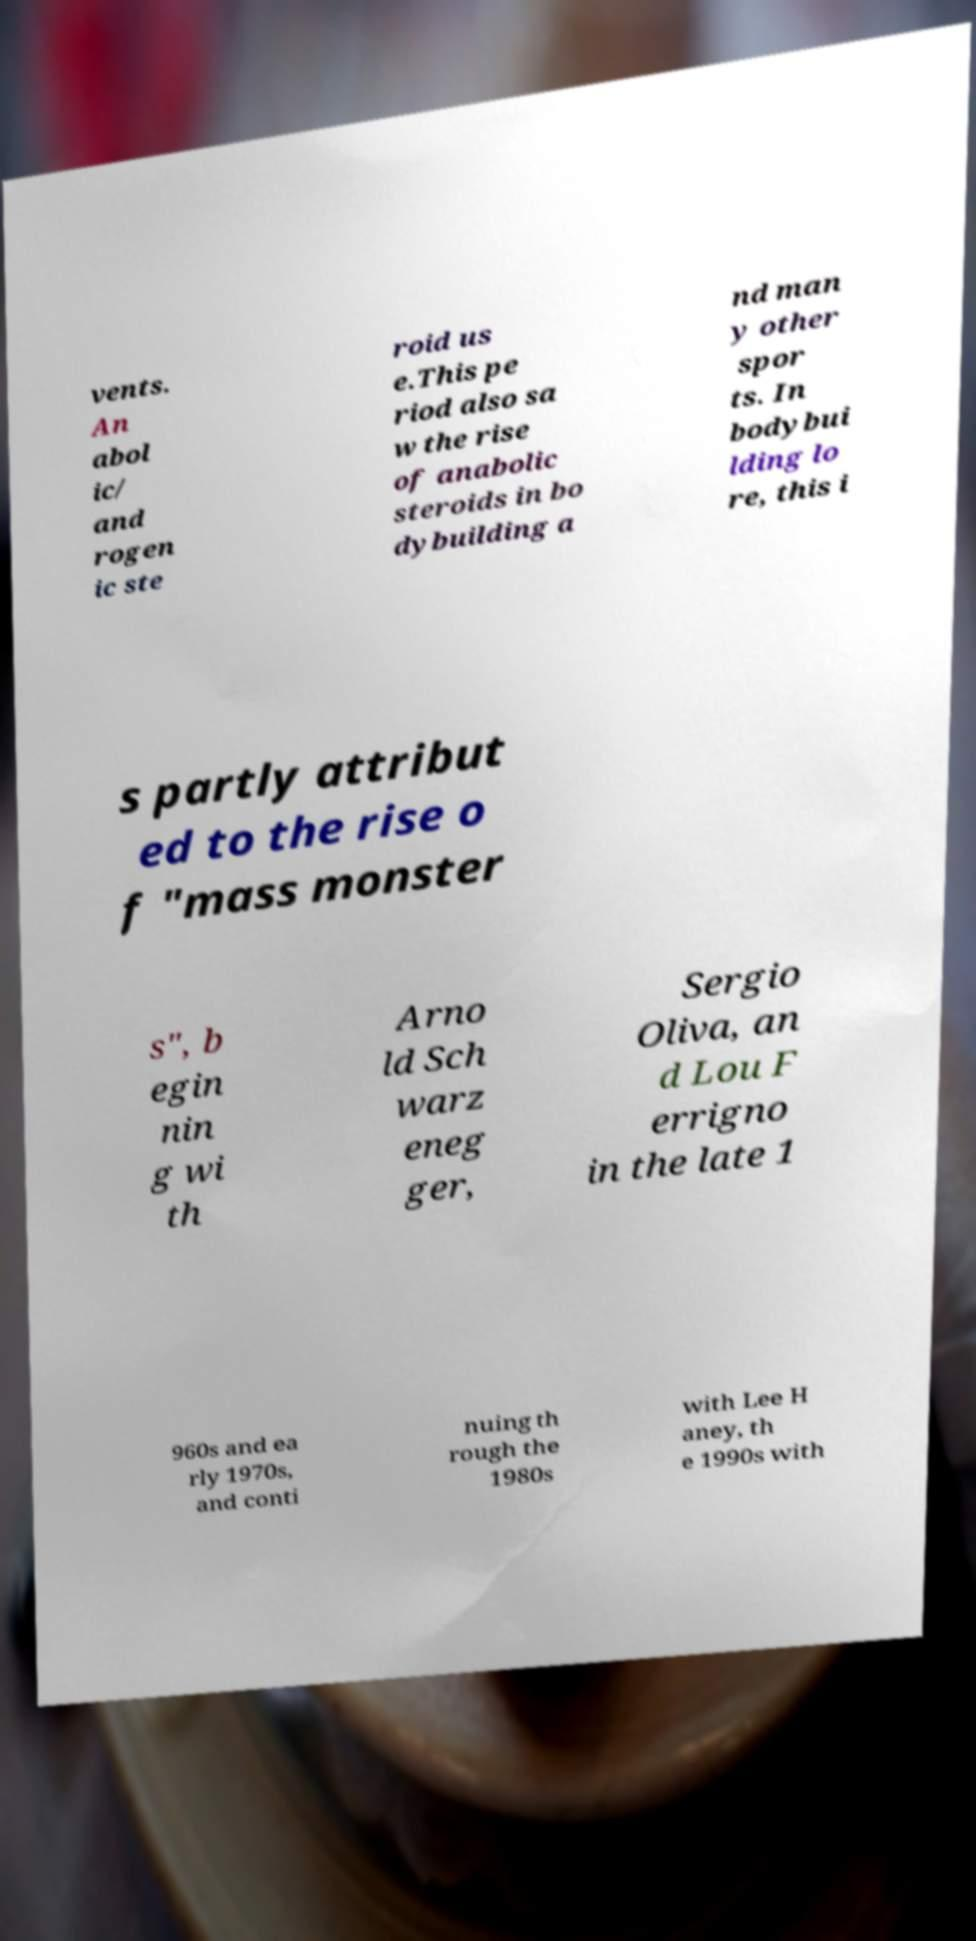Can you read and provide the text displayed in the image?This photo seems to have some interesting text. Can you extract and type it out for me? vents. An abol ic/ and rogen ic ste roid us e.This pe riod also sa w the rise of anabolic steroids in bo dybuilding a nd man y other spor ts. In bodybui lding lo re, this i s partly attribut ed to the rise o f "mass monster s", b egin nin g wi th Arno ld Sch warz eneg ger, Sergio Oliva, an d Lou F errigno in the late 1 960s and ea rly 1970s, and conti nuing th rough the 1980s with Lee H aney, th e 1990s with 